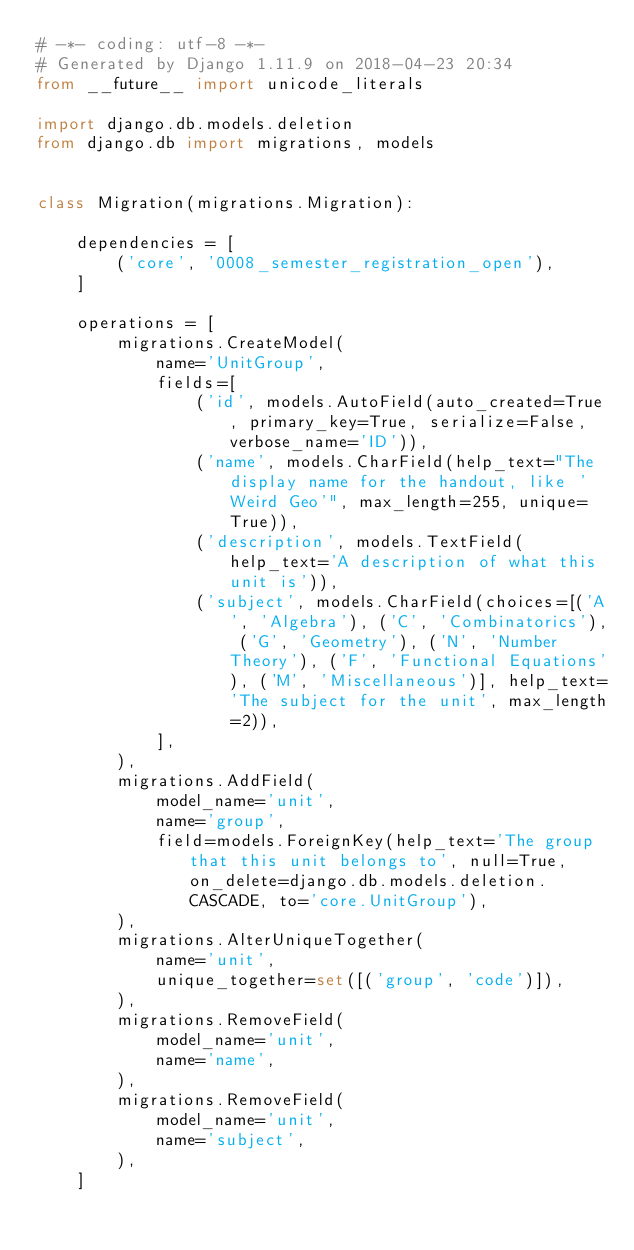Convert code to text. <code><loc_0><loc_0><loc_500><loc_500><_Python_># -*- coding: utf-8 -*-
# Generated by Django 1.11.9 on 2018-04-23 20:34
from __future__ import unicode_literals

import django.db.models.deletion
from django.db import migrations, models


class Migration(migrations.Migration):

    dependencies = [
        ('core', '0008_semester_registration_open'),
    ]

    operations = [
        migrations.CreateModel(
            name='UnitGroup',
            fields=[
                ('id', models.AutoField(auto_created=True, primary_key=True, serialize=False, verbose_name='ID')),
                ('name', models.CharField(help_text="The display name for the handout, like 'Weird Geo'", max_length=255, unique=True)),
                ('description', models.TextField(help_text='A description of what this unit is')),
                ('subject', models.CharField(choices=[('A', 'Algebra'), ('C', 'Combinatorics'), ('G', 'Geometry'), ('N', 'Number Theory'), ('F', 'Functional Equations'), ('M', 'Miscellaneous')], help_text='The subject for the unit', max_length=2)),
            ],
        ),
        migrations.AddField(
            model_name='unit',
            name='group',
            field=models.ForeignKey(help_text='The group that this unit belongs to', null=True, on_delete=django.db.models.deletion.CASCADE, to='core.UnitGroup'),
        ),
        migrations.AlterUniqueTogether(
            name='unit',
            unique_together=set([('group', 'code')]),
        ),
        migrations.RemoveField(
            model_name='unit',
            name='name',
        ),
        migrations.RemoveField(
            model_name='unit',
            name='subject',
        ),
    ]
</code> 